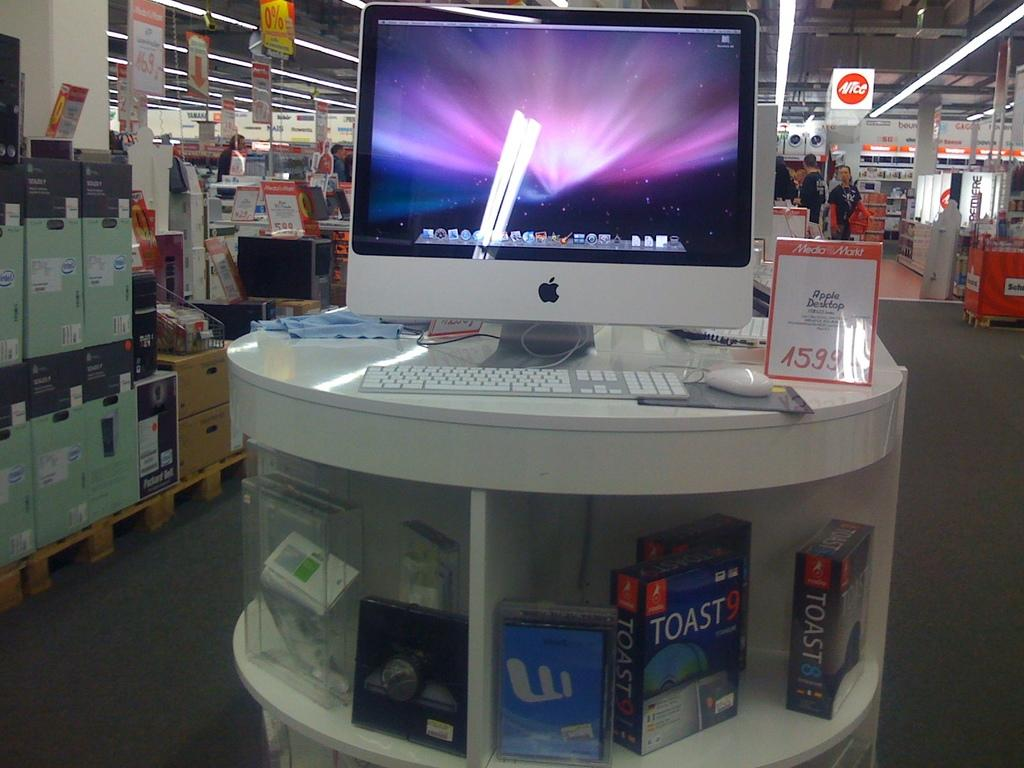<image>
Present a compact description of the photo's key features. The Apple Desktop store display includes Toast software versions 8 and 9. 